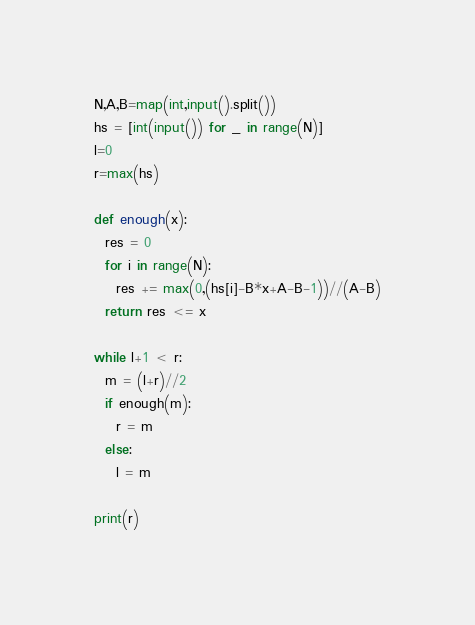Convert code to text. <code><loc_0><loc_0><loc_500><loc_500><_Python_>N,A,B=map(int,input().split())
hs = [int(input()) for _ in range(N)]
l=0
r=max(hs)

def enough(x):
  res = 0
  for i in range(N):
    res += max(0,(hs[i]-B*x+A-B-1))//(A-B)
  return res <= x

while l+1 < r:
  m = (l+r)//2
  if enough(m):
    r = m
  else:
    l = m

print(r)</code> 